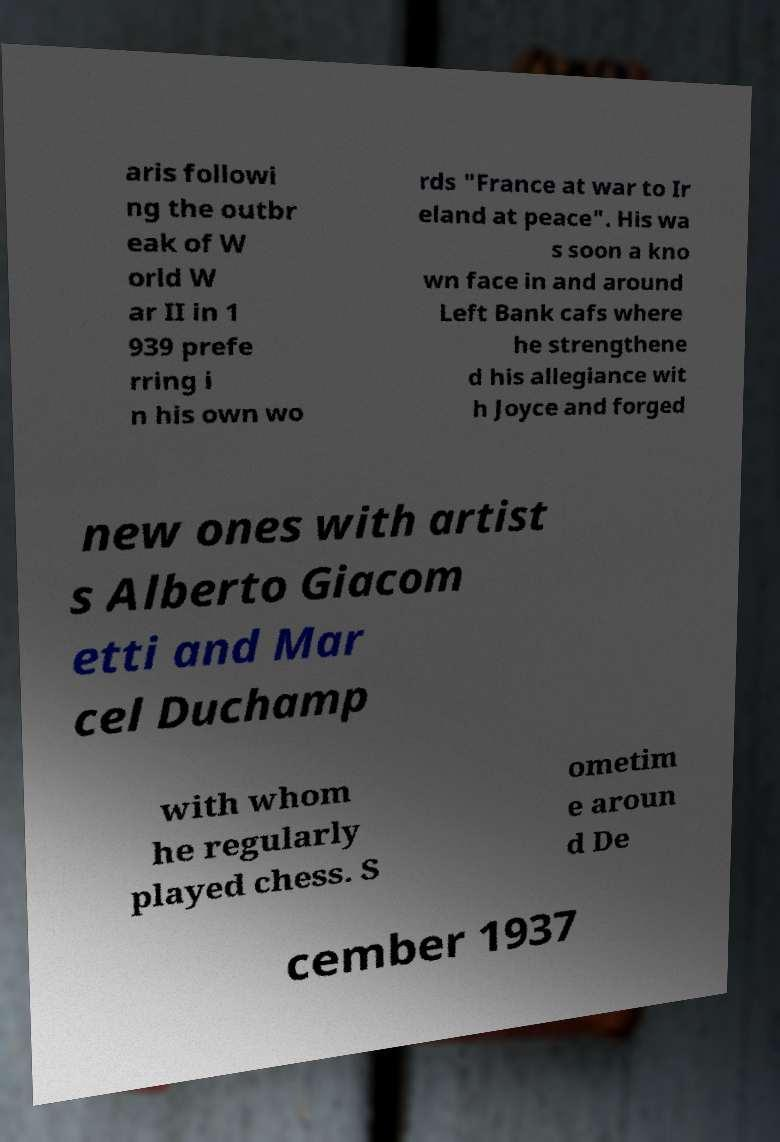Could you extract and type out the text from this image? aris followi ng the outbr eak of W orld W ar II in 1 939 prefe rring i n his own wo rds "France at war to Ir eland at peace". His wa s soon a kno wn face in and around Left Bank cafs where he strengthene d his allegiance wit h Joyce and forged new ones with artist s Alberto Giacom etti and Mar cel Duchamp with whom he regularly played chess. S ometim e aroun d De cember 1937 